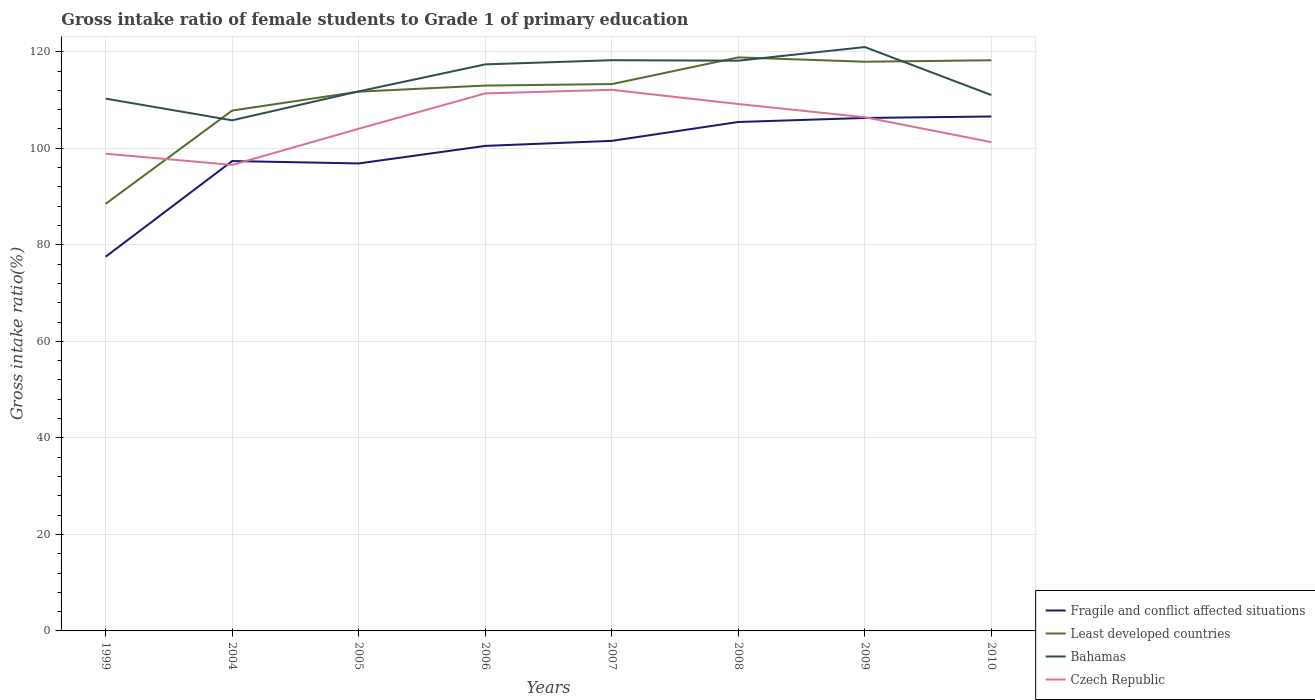Does the line corresponding to Bahamas intersect with the line corresponding to Fragile and conflict affected situations?
Your answer should be very brief. No. Across all years, what is the maximum gross intake ratio in Czech Republic?
Your answer should be compact. 96.55. What is the total gross intake ratio in Fragile and conflict affected situations in the graph?
Your answer should be very brief. -22.96. What is the difference between the highest and the second highest gross intake ratio in Fragile and conflict affected situations?
Ensure brevity in your answer.  29.05. How many lines are there?
Ensure brevity in your answer.  4. What is the difference between two consecutive major ticks on the Y-axis?
Keep it short and to the point. 20. Does the graph contain grids?
Ensure brevity in your answer.  Yes. How many legend labels are there?
Give a very brief answer. 4. What is the title of the graph?
Your response must be concise. Gross intake ratio of female students to Grade 1 of primary education. Does "Mauritius" appear as one of the legend labels in the graph?
Make the answer very short. No. What is the label or title of the X-axis?
Offer a terse response. Years. What is the label or title of the Y-axis?
Your answer should be very brief. Gross intake ratio(%). What is the Gross intake ratio(%) of Fragile and conflict affected situations in 1999?
Your response must be concise. 77.53. What is the Gross intake ratio(%) of Least developed countries in 1999?
Provide a short and direct response. 88.5. What is the Gross intake ratio(%) of Bahamas in 1999?
Give a very brief answer. 110.28. What is the Gross intake ratio(%) in Czech Republic in 1999?
Ensure brevity in your answer.  98.87. What is the Gross intake ratio(%) in Fragile and conflict affected situations in 2004?
Your response must be concise. 97.35. What is the Gross intake ratio(%) of Least developed countries in 2004?
Your answer should be compact. 107.81. What is the Gross intake ratio(%) of Bahamas in 2004?
Provide a short and direct response. 105.79. What is the Gross intake ratio(%) of Czech Republic in 2004?
Your response must be concise. 96.55. What is the Gross intake ratio(%) in Fragile and conflict affected situations in 2005?
Offer a very short reply. 96.86. What is the Gross intake ratio(%) in Least developed countries in 2005?
Provide a short and direct response. 111.72. What is the Gross intake ratio(%) of Bahamas in 2005?
Offer a terse response. 111.79. What is the Gross intake ratio(%) of Czech Republic in 2005?
Offer a terse response. 104.04. What is the Gross intake ratio(%) in Fragile and conflict affected situations in 2006?
Ensure brevity in your answer.  100.49. What is the Gross intake ratio(%) in Least developed countries in 2006?
Your answer should be very brief. 112.99. What is the Gross intake ratio(%) of Bahamas in 2006?
Your answer should be very brief. 117.38. What is the Gross intake ratio(%) of Czech Republic in 2006?
Your answer should be compact. 111.36. What is the Gross intake ratio(%) in Fragile and conflict affected situations in 2007?
Keep it short and to the point. 101.53. What is the Gross intake ratio(%) in Least developed countries in 2007?
Provide a succinct answer. 113.3. What is the Gross intake ratio(%) in Bahamas in 2007?
Offer a terse response. 118.24. What is the Gross intake ratio(%) of Czech Republic in 2007?
Your answer should be compact. 112.11. What is the Gross intake ratio(%) of Fragile and conflict affected situations in 2008?
Give a very brief answer. 105.44. What is the Gross intake ratio(%) in Least developed countries in 2008?
Provide a succinct answer. 118.83. What is the Gross intake ratio(%) in Bahamas in 2008?
Provide a short and direct response. 118.14. What is the Gross intake ratio(%) of Czech Republic in 2008?
Provide a succinct answer. 109.16. What is the Gross intake ratio(%) in Fragile and conflict affected situations in 2009?
Your answer should be very brief. 106.28. What is the Gross intake ratio(%) in Least developed countries in 2009?
Make the answer very short. 117.93. What is the Gross intake ratio(%) in Bahamas in 2009?
Your answer should be very brief. 120.97. What is the Gross intake ratio(%) in Czech Republic in 2009?
Offer a very short reply. 106.43. What is the Gross intake ratio(%) of Fragile and conflict affected situations in 2010?
Offer a very short reply. 106.58. What is the Gross intake ratio(%) of Least developed countries in 2010?
Keep it short and to the point. 118.23. What is the Gross intake ratio(%) of Bahamas in 2010?
Offer a terse response. 111.02. What is the Gross intake ratio(%) of Czech Republic in 2010?
Your answer should be compact. 101.27. Across all years, what is the maximum Gross intake ratio(%) in Fragile and conflict affected situations?
Your answer should be very brief. 106.58. Across all years, what is the maximum Gross intake ratio(%) in Least developed countries?
Your answer should be very brief. 118.83. Across all years, what is the maximum Gross intake ratio(%) in Bahamas?
Ensure brevity in your answer.  120.97. Across all years, what is the maximum Gross intake ratio(%) of Czech Republic?
Your answer should be very brief. 112.11. Across all years, what is the minimum Gross intake ratio(%) in Fragile and conflict affected situations?
Ensure brevity in your answer.  77.53. Across all years, what is the minimum Gross intake ratio(%) of Least developed countries?
Provide a succinct answer. 88.5. Across all years, what is the minimum Gross intake ratio(%) of Bahamas?
Provide a succinct answer. 105.79. Across all years, what is the minimum Gross intake ratio(%) in Czech Republic?
Your response must be concise. 96.55. What is the total Gross intake ratio(%) of Fragile and conflict affected situations in the graph?
Keep it short and to the point. 792.07. What is the total Gross intake ratio(%) in Least developed countries in the graph?
Give a very brief answer. 889.3. What is the total Gross intake ratio(%) of Bahamas in the graph?
Ensure brevity in your answer.  913.61. What is the total Gross intake ratio(%) of Czech Republic in the graph?
Give a very brief answer. 839.79. What is the difference between the Gross intake ratio(%) in Fragile and conflict affected situations in 1999 and that in 2004?
Ensure brevity in your answer.  -19.82. What is the difference between the Gross intake ratio(%) in Least developed countries in 1999 and that in 2004?
Your answer should be compact. -19.31. What is the difference between the Gross intake ratio(%) of Bahamas in 1999 and that in 2004?
Give a very brief answer. 4.49. What is the difference between the Gross intake ratio(%) of Czech Republic in 1999 and that in 2004?
Offer a very short reply. 2.31. What is the difference between the Gross intake ratio(%) of Fragile and conflict affected situations in 1999 and that in 2005?
Your answer should be compact. -19.32. What is the difference between the Gross intake ratio(%) in Least developed countries in 1999 and that in 2005?
Your answer should be compact. -23.22. What is the difference between the Gross intake ratio(%) in Bahamas in 1999 and that in 2005?
Offer a terse response. -1.51. What is the difference between the Gross intake ratio(%) in Czech Republic in 1999 and that in 2005?
Offer a terse response. -5.17. What is the difference between the Gross intake ratio(%) of Fragile and conflict affected situations in 1999 and that in 2006?
Provide a succinct answer. -22.96. What is the difference between the Gross intake ratio(%) in Least developed countries in 1999 and that in 2006?
Offer a terse response. -24.49. What is the difference between the Gross intake ratio(%) in Bahamas in 1999 and that in 2006?
Your answer should be compact. -7.1. What is the difference between the Gross intake ratio(%) in Czech Republic in 1999 and that in 2006?
Ensure brevity in your answer.  -12.5. What is the difference between the Gross intake ratio(%) in Fragile and conflict affected situations in 1999 and that in 2007?
Make the answer very short. -24. What is the difference between the Gross intake ratio(%) in Least developed countries in 1999 and that in 2007?
Offer a terse response. -24.8. What is the difference between the Gross intake ratio(%) of Bahamas in 1999 and that in 2007?
Offer a very short reply. -7.96. What is the difference between the Gross intake ratio(%) of Czech Republic in 1999 and that in 2007?
Your answer should be very brief. -13.24. What is the difference between the Gross intake ratio(%) of Fragile and conflict affected situations in 1999 and that in 2008?
Give a very brief answer. -27.91. What is the difference between the Gross intake ratio(%) in Least developed countries in 1999 and that in 2008?
Provide a short and direct response. -30.33. What is the difference between the Gross intake ratio(%) of Bahamas in 1999 and that in 2008?
Keep it short and to the point. -7.86. What is the difference between the Gross intake ratio(%) in Czech Republic in 1999 and that in 2008?
Keep it short and to the point. -10.29. What is the difference between the Gross intake ratio(%) of Fragile and conflict affected situations in 1999 and that in 2009?
Offer a terse response. -28.75. What is the difference between the Gross intake ratio(%) in Least developed countries in 1999 and that in 2009?
Your response must be concise. -29.43. What is the difference between the Gross intake ratio(%) of Bahamas in 1999 and that in 2009?
Your response must be concise. -10.69. What is the difference between the Gross intake ratio(%) of Czech Republic in 1999 and that in 2009?
Keep it short and to the point. -7.56. What is the difference between the Gross intake ratio(%) of Fragile and conflict affected situations in 1999 and that in 2010?
Give a very brief answer. -29.05. What is the difference between the Gross intake ratio(%) in Least developed countries in 1999 and that in 2010?
Make the answer very short. -29.73. What is the difference between the Gross intake ratio(%) of Bahamas in 1999 and that in 2010?
Offer a very short reply. -0.74. What is the difference between the Gross intake ratio(%) of Czech Republic in 1999 and that in 2010?
Keep it short and to the point. -2.41. What is the difference between the Gross intake ratio(%) of Fragile and conflict affected situations in 2004 and that in 2005?
Your answer should be very brief. 0.49. What is the difference between the Gross intake ratio(%) in Least developed countries in 2004 and that in 2005?
Your answer should be very brief. -3.91. What is the difference between the Gross intake ratio(%) in Bahamas in 2004 and that in 2005?
Your response must be concise. -6. What is the difference between the Gross intake ratio(%) of Czech Republic in 2004 and that in 2005?
Offer a very short reply. -7.49. What is the difference between the Gross intake ratio(%) of Fragile and conflict affected situations in 2004 and that in 2006?
Your answer should be compact. -3.14. What is the difference between the Gross intake ratio(%) in Least developed countries in 2004 and that in 2006?
Provide a short and direct response. -5.18. What is the difference between the Gross intake ratio(%) in Bahamas in 2004 and that in 2006?
Offer a terse response. -11.59. What is the difference between the Gross intake ratio(%) of Czech Republic in 2004 and that in 2006?
Keep it short and to the point. -14.81. What is the difference between the Gross intake ratio(%) in Fragile and conflict affected situations in 2004 and that in 2007?
Keep it short and to the point. -4.18. What is the difference between the Gross intake ratio(%) of Least developed countries in 2004 and that in 2007?
Offer a terse response. -5.48. What is the difference between the Gross intake ratio(%) of Bahamas in 2004 and that in 2007?
Keep it short and to the point. -12.46. What is the difference between the Gross intake ratio(%) in Czech Republic in 2004 and that in 2007?
Make the answer very short. -15.55. What is the difference between the Gross intake ratio(%) in Fragile and conflict affected situations in 2004 and that in 2008?
Ensure brevity in your answer.  -8.09. What is the difference between the Gross intake ratio(%) in Least developed countries in 2004 and that in 2008?
Your response must be concise. -11.01. What is the difference between the Gross intake ratio(%) of Bahamas in 2004 and that in 2008?
Ensure brevity in your answer.  -12.36. What is the difference between the Gross intake ratio(%) in Czech Republic in 2004 and that in 2008?
Keep it short and to the point. -12.6. What is the difference between the Gross intake ratio(%) in Fragile and conflict affected situations in 2004 and that in 2009?
Your response must be concise. -8.93. What is the difference between the Gross intake ratio(%) in Least developed countries in 2004 and that in 2009?
Ensure brevity in your answer.  -10.12. What is the difference between the Gross intake ratio(%) in Bahamas in 2004 and that in 2009?
Your response must be concise. -15.18. What is the difference between the Gross intake ratio(%) in Czech Republic in 2004 and that in 2009?
Offer a very short reply. -9.87. What is the difference between the Gross intake ratio(%) of Fragile and conflict affected situations in 2004 and that in 2010?
Offer a very short reply. -9.23. What is the difference between the Gross intake ratio(%) of Least developed countries in 2004 and that in 2010?
Offer a terse response. -10.42. What is the difference between the Gross intake ratio(%) in Bahamas in 2004 and that in 2010?
Offer a very short reply. -5.24. What is the difference between the Gross intake ratio(%) of Czech Republic in 2004 and that in 2010?
Keep it short and to the point. -4.72. What is the difference between the Gross intake ratio(%) in Fragile and conflict affected situations in 2005 and that in 2006?
Your response must be concise. -3.63. What is the difference between the Gross intake ratio(%) in Least developed countries in 2005 and that in 2006?
Your response must be concise. -1.27. What is the difference between the Gross intake ratio(%) in Bahamas in 2005 and that in 2006?
Your response must be concise. -5.59. What is the difference between the Gross intake ratio(%) in Czech Republic in 2005 and that in 2006?
Ensure brevity in your answer.  -7.32. What is the difference between the Gross intake ratio(%) in Fragile and conflict affected situations in 2005 and that in 2007?
Your answer should be compact. -4.68. What is the difference between the Gross intake ratio(%) of Least developed countries in 2005 and that in 2007?
Make the answer very short. -1.57. What is the difference between the Gross intake ratio(%) of Bahamas in 2005 and that in 2007?
Your answer should be very brief. -6.46. What is the difference between the Gross intake ratio(%) in Czech Republic in 2005 and that in 2007?
Keep it short and to the point. -8.07. What is the difference between the Gross intake ratio(%) of Fragile and conflict affected situations in 2005 and that in 2008?
Offer a very short reply. -8.59. What is the difference between the Gross intake ratio(%) in Least developed countries in 2005 and that in 2008?
Your answer should be compact. -7.1. What is the difference between the Gross intake ratio(%) of Bahamas in 2005 and that in 2008?
Keep it short and to the point. -6.36. What is the difference between the Gross intake ratio(%) of Czech Republic in 2005 and that in 2008?
Provide a short and direct response. -5.11. What is the difference between the Gross intake ratio(%) of Fragile and conflict affected situations in 2005 and that in 2009?
Give a very brief answer. -9.42. What is the difference between the Gross intake ratio(%) of Least developed countries in 2005 and that in 2009?
Your answer should be compact. -6.21. What is the difference between the Gross intake ratio(%) in Bahamas in 2005 and that in 2009?
Your answer should be compact. -9.18. What is the difference between the Gross intake ratio(%) in Czech Republic in 2005 and that in 2009?
Your answer should be very brief. -2.39. What is the difference between the Gross intake ratio(%) in Fragile and conflict affected situations in 2005 and that in 2010?
Provide a short and direct response. -9.73. What is the difference between the Gross intake ratio(%) in Least developed countries in 2005 and that in 2010?
Your answer should be compact. -6.51. What is the difference between the Gross intake ratio(%) in Bahamas in 2005 and that in 2010?
Your answer should be compact. 0.76. What is the difference between the Gross intake ratio(%) in Czech Republic in 2005 and that in 2010?
Make the answer very short. 2.77. What is the difference between the Gross intake ratio(%) in Fragile and conflict affected situations in 2006 and that in 2007?
Keep it short and to the point. -1.04. What is the difference between the Gross intake ratio(%) of Least developed countries in 2006 and that in 2007?
Your answer should be compact. -0.31. What is the difference between the Gross intake ratio(%) of Bahamas in 2006 and that in 2007?
Offer a very short reply. -0.87. What is the difference between the Gross intake ratio(%) in Czech Republic in 2006 and that in 2007?
Give a very brief answer. -0.74. What is the difference between the Gross intake ratio(%) of Fragile and conflict affected situations in 2006 and that in 2008?
Provide a succinct answer. -4.95. What is the difference between the Gross intake ratio(%) in Least developed countries in 2006 and that in 2008?
Your answer should be compact. -5.83. What is the difference between the Gross intake ratio(%) in Bahamas in 2006 and that in 2008?
Your answer should be compact. -0.76. What is the difference between the Gross intake ratio(%) in Czech Republic in 2006 and that in 2008?
Make the answer very short. 2.21. What is the difference between the Gross intake ratio(%) in Fragile and conflict affected situations in 2006 and that in 2009?
Provide a succinct answer. -5.79. What is the difference between the Gross intake ratio(%) of Least developed countries in 2006 and that in 2009?
Keep it short and to the point. -4.94. What is the difference between the Gross intake ratio(%) of Bahamas in 2006 and that in 2009?
Offer a terse response. -3.59. What is the difference between the Gross intake ratio(%) in Czech Republic in 2006 and that in 2009?
Offer a terse response. 4.94. What is the difference between the Gross intake ratio(%) in Fragile and conflict affected situations in 2006 and that in 2010?
Your answer should be very brief. -6.09. What is the difference between the Gross intake ratio(%) of Least developed countries in 2006 and that in 2010?
Provide a succinct answer. -5.24. What is the difference between the Gross intake ratio(%) in Bahamas in 2006 and that in 2010?
Your answer should be compact. 6.35. What is the difference between the Gross intake ratio(%) in Czech Republic in 2006 and that in 2010?
Ensure brevity in your answer.  10.09. What is the difference between the Gross intake ratio(%) of Fragile and conflict affected situations in 2007 and that in 2008?
Your answer should be compact. -3.91. What is the difference between the Gross intake ratio(%) of Least developed countries in 2007 and that in 2008?
Your response must be concise. -5.53. What is the difference between the Gross intake ratio(%) in Bahamas in 2007 and that in 2008?
Your answer should be very brief. 0.1. What is the difference between the Gross intake ratio(%) in Czech Republic in 2007 and that in 2008?
Ensure brevity in your answer.  2.95. What is the difference between the Gross intake ratio(%) of Fragile and conflict affected situations in 2007 and that in 2009?
Keep it short and to the point. -4.75. What is the difference between the Gross intake ratio(%) in Least developed countries in 2007 and that in 2009?
Keep it short and to the point. -4.63. What is the difference between the Gross intake ratio(%) in Bahamas in 2007 and that in 2009?
Provide a short and direct response. -2.72. What is the difference between the Gross intake ratio(%) of Czech Republic in 2007 and that in 2009?
Ensure brevity in your answer.  5.68. What is the difference between the Gross intake ratio(%) of Fragile and conflict affected situations in 2007 and that in 2010?
Provide a succinct answer. -5.05. What is the difference between the Gross intake ratio(%) in Least developed countries in 2007 and that in 2010?
Your response must be concise. -4.93. What is the difference between the Gross intake ratio(%) in Bahamas in 2007 and that in 2010?
Keep it short and to the point. 7.22. What is the difference between the Gross intake ratio(%) in Czech Republic in 2007 and that in 2010?
Keep it short and to the point. 10.83. What is the difference between the Gross intake ratio(%) in Fragile and conflict affected situations in 2008 and that in 2009?
Ensure brevity in your answer.  -0.84. What is the difference between the Gross intake ratio(%) of Least developed countries in 2008 and that in 2009?
Give a very brief answer. 0.9. What is the difference between the Gross intake ratio(%) in Bahamas in 2008 and that in 2009?
Make the answer very short. -2.82. What is the difference between the Gross intake ratio(%) of Czech Republic in 2008 and that in 2009?
Ensure brevity in your answer.  2.73. What is the difference between the Gross intake ratio(%) in Fragile and conflict affected situations in 2008 and that in 2010?
Your answer should be compact. -1.14. What is the difference between the Gross intake ratio(%) of Least developed countries in 2008 and that in 2010?
Your response must be concise. 0.6. What is the difference between the Gross intake ratio(%) in Bahamas in 2008 and that in 2010?
Your answer should be very brief. 7.12. What is the difference between the Gross intake ratio(%) of Czech Republic in 2008 and that in 2010?
Provide a succinct answer. 7.88. What is the difference between the Gross intake ratio(%) in Fragile and conflict affected situations in 2009 and that in 2010?
Offer a terse response. -0.3. What is the difference between the Gross intake ratio(%) in Least developed countries in 2009 and that in 2010?
Offer a terse response. -0.3. What is the difference between the Gross intake ratio(%) in Bahamas in 2009 and that in 2010?
Your answer should be compact. 9.94. What is the difference between the Gross intake ratio(%) in Czech Republic in 2009 and that in 2010?
Make the answer very short. 5.15. What is the difference between the Gross intake ratio(%) in Fragile and conflict affected situations in 1999 and the Gross intake ratio(%) in Least developed countries in 2004?
Give a very brief answer. -30.28. What is the difference between the Gross intake ratio(%) in Fragile and conflict affected situations in 1999 and the Gross intake ratio(%) in Bahamas in 2004?
Provide a succinct answer. -28.26. What is the difference between the Gross intake ratio(%) of Fragile and conflict affected situations in 1999 and the Gross intake ratio(%) of Czech Republic in 2004?
Provide a succinct answer. -19.02. What is the difference between the Gross intake ratio(%) of Least developed countries in 1999 and the Gross intake ratio(%) of Bahamas in 2004?
Keep it short and to the point. -17.29. What is the difference between the Gross intake ratio(%) in Least developed countries in 1999 and the Gross intake ratio(%) in Czech Republic in 2004?
Your answer should be very brief. -8.05. What is the difference between the Gross intake ratio(%) in Bahamas in 1999 and the Gross intake ratio(%) in Czech Republic in 2004?
Offer a very short reply. 13.73. What is the difference between the Gross intake ratio(%) in Fragile and conflict affected situations in 1999 and the Gross intake ratio(%) in Least developed countries in 2005?
Provide a succinct answer. -34.19. What is the difference between the Gross intake ratio(%) in Fragile and conflict affected situations in 1999 and the Gross intake ratio(%) in Bahamas in 2005?
Offer a very short reply. -34.26. What is the difference between the Gross intake ratio(%) in Fragile and conflict affected situations in 1999 and the Gross intake ratio(%) in Czech Republic in 2005?
Offer a terse response. -26.51. What is the difference between the Gross intake ratio(%) of Least developed countries in 1999 and the Gross intake ratio(%) of Bahamas in 2005?
Your response must be concise. -23.29. What is the difference between the Gross intake ratio(%) of Least developed countries in 1999 and the Gross intake ratio(%) of Czech Republic in 2005?
Provide a succinct answer. -15.54. What is the difference between the Gross intake ratio(%) in Bahamas in 1999 and the Gross intake ratio(%) in Czech Republic in 2005?
Provide a succinct answer. 6.24. What is the difference between the Gross intake ratio(%) in Fragile and conflict affected situations in 1999 and the Gross intake ratio(%) in Least developed countries in 2006?
Offer a terse response. -35.46. What is the difference between the Gross intake ratio(%) of Fragile and conflict affected situations in 1999 and the Gross intake ratio(%) of Bahamas in 2006?
Your answer should be very brief. -39.85. What is the difference between the Gross intake ratio(%) of Fragile and conflict affected situations in 1999 and the Gross intake ratio(%) of Czech Republic in 2006?
Make the answer very short. -33.83. What is the difference between the Gross intake ratio(%) in Least developed countries in 1999 and the Gross intake ratio(%) in Bahamas in 2006?
Ensure brevity in your answer.  -28.88. What is the difference between the Gross intake ratio(%) of Least developed countries in 1999 and the Gross intake ratio(%) of Czech Republic in 2006?
Give a very brief answer. -22.87. What is the difference between the Gross intake ratio(%) in Bahamas in 1999 and the Gross intake ratio(%) in Czech Republic in 2006?
Provide a short and direct response. -1.08. What is the difference between the Gross intake ratio(%) in Fragile and conflict affected situations in 1999 and the Gross intake ratio(%) in Least developed countries in 2007?
Offer a terse response. -35.76. What is the difference between the Gross intake ratio(%) of Fragile and conflict affected situations in 1999 and the Gross intake ratio(%) of Bahamas in 2007?
Keep it short and to the point. -40.71. What is the difference between the Gross intake ratio(%) of Fragile and conflict affected situations in 1999 and the Gross intake ratio(%) of Czech Republic in 2007?
Make the answer very short. -34.58. What is the difference between the Gross intake ratio(%) of Least developed countries in 1999 and the Gross intake ratio(%) of Bahamas in 2007?
Provide a short and direct response. -29.75. What is the difference between the Gross intake ratio(%) of Least developed countries in 1999 and the Gross intake ratio(%) of Czech Republic in 2007?
Your answer should be very brief. -23.61. What is the difference between the Gross intake ratio(%) in Bahamas in 1999 and the Gross intake ratio(%) in Czech Republic in 2007?
Your answer should be compact. -1.83. What is the difference between the Gross intake ratio(%) of Fragile and conflict affected situations in 1999 and the Gross intake ratio(%) of Least developed countries in 2008?
Keep it short and to the point. -41.29. What is the difference between the Gross intake ratio(%) of Fragile and conflict affected situations in 1999 and the Gross intake ratio(%) of Bahamas in 2008?
Provide a short and direct response. -40.61. What is the difference between the Gross intake ratio(%) in Fragile and conflict affected situations in 1999 and the Gross intake ratio(%) in Czech Republic in 2008?
Ensure brevity in your answer.  -31.63. What is the difference between the Gross intake ratio(%) of Least developed countries in 1999 and the Gross intake ratio(%) of Bahamas in 2008?
Keep it short and to the point. -29.64. What is the difference between the Gross intake ratio(%) of Least developed countries in 1999 and the Gross intake ratio(%) of Czech Republic in 2008?
Make the answer very short. -20.66. What is the difference between the Gross intake ratio(%) in Bahamas in 1999 and the Gross intake ratio(%) in Czech Republic in 2008?
Give a very brief answer. 1.12. What is the difference between the Gross intake ratio(%) in Fragile and conflict affected situations in 1999 and the Gross intake ratio(%) in Least developed countries in 2009?
Offer a very short reply. -40.4. What is the difference between the Gross intake ratio(%) of Fragile and conflict affected situations in 1999 and the Gross intake ratio(%) of Bahamas in 2009?
Make the answer very short. -43.44. What is the difference between the Gross intake ratio(%) in Fragile and conflict affected situations in 1999 and the Gross intake ratio(%) in Czech Republic in 2009?
Provide a succinct answer. -28.9. What is the difference between the Gross intake ratio(%) of Least developed countries in 1999 and the Gross intake ratio(%) of Bahamas in 2009?
Provide a short and direct response. -32.47. What is the difference between the Gross intake ratio(%) in Least developed countries in 1999 and the Gross intake ratio(%) in Czech Republic in 2009?
Your answer should be very brief. -17.93. What is the difference between the Gross intake ratio(%) of Bahamas in 1999 and the Gross intake ratio(%) of Czech Republic in 2009?
Provide a succinct answer. 3.85. What is the difference between the Gross intake ratio(%) in Fragile and conflict affected situations in 1999 and the Gross intake ratio(%) in Least developed countries in 2010?
Your answer should be very brief. -40.7. What is the difference between the Gross intake ratio(%) of Fragile and conflict affected situations in 1999 and the Gross intake ratio(%) of Bahamas in 2010?
Your answer should be very brief. -33.49. What is the difference between the Gross intake ratio(%) of Fragile and conflict affected situations in 1999 and the Gross intake ratio(%) of Czech Republic in 2010?
Provide a succinct answer. -23.74. What is the difference between the Gross intake ratio(%) of Least developed countries in 1999 and the Gross intake ratio(%) of Bahamas in 2010?
Provide a succinct answer. -22.52. What is the difference between the Gross intake ratio(%) of Least developed countries in 1999 and the Gross intake ratio(%) of Czech Republic in 2010?
Provide a short and direct response. -12.77. What is the difference between the Gross intake ratio(%) in Bahamas in 1999 and the Gross intake ratio(%) in Czech Republic in 2010?
Ensure brevity in your answer.  9.01. What is the difference between the Gross intake ratio(%) of Fragile and conflict affected situations in 2004 and the Gross intake ratio(%) of Least developed countries in 2005?
Provide a short and direct response. -14.37. What is the difference between the Gross intake ratio(%) in Fragile and conflict affected situations in 2004 and the Gross intake ratio(%) in Bahamas in 2005?
Provide a short and direct response. -14.44. What is the difference between the Gross intake ratio(%) in Fragile and conflict affected situations in 2004 and the Gross intake ratio(%) in Czech Republic in 2005?
Offer a very short reply. -6.69. What is the difference between the Gross intake ratio(%) of Least developed countries in 2004 and the Gross intake ratio(%) of Bahamas in 2005?
Make the answer very short. -3.97. What is the difference between the Gross intake ratio(%) of Least developed countries in 2004 and the Gross intake ratio(%) of Czech Republic in 2005?
Your answer should be compact. 3.77. What is the difference between the Gross intake ratio(%) in Bahamas in 2004 and the Gross intake ratio(%) in Czech Republic in 2005?
Provide a short and direct response. 1.75. What is the difference between the Gross intake ratio(%) of Fragile and conflict affected situations in 2004 and the Gross intake ratio(%) of Least developed countries in 2006?
Your response must be concise. -15.64. What is the difference between the Gross intake ratio(%) in Fragile and conflict affected situations in 2004 and the Gross intake ratio(%) in Bahamas in 2006?
Provide a short and direct response. -20.03. What is the difference between the Gross intake ratio(%) of Fragile and conflict affected situations in 2004 and the Gross intake ratio(%) of Czech Republic in 2006?
Your answer should be compact. -14.01. What is the difference between the Gross intake ratio(%) in Least developed countries in 2004 and the Gross intake ratio(%) in Bahamas in 2006?
Your answer should be compact. -9.56. What is the difference between the Gross intake ratio(%) in Least developed countries in 2004 and the Gross intake ratio(%) in Czech Republic in 2006?
Your response must be concise. -3.55. What is the difference between the Gross intake ratio(%) in Bahamas in 2004 and the Gross intake ratio(%) in Czech Republic in 2006?
Keep it short and to the point. -5.58. What is the difference between the Gross intake ratio(%) in Fragile and conflict affected situations in 2004 and the Gross intake ratio(%) in Least developed countries in 2007?
Make the answer very short. -15.95. What is the difference between the Gross intake ratio(%) in Fragile and conflict affected situations in 2004 and the Gross intake ratio(%) in Bahamas in 2007?
Ensure brevity in your answer.  -20.89. What is the difference between the Gross intake ratio(%) of Fragile and conflict affected situations in 2004 and the Gross intake ratio(%) of Czech Republic in 2007?
Offer a very short reply. -14.76. What is the difference between the Gross intake ratio(%) of Least developed countries in 2004 and the Gross intake ratio(%) of Bahamas in 2007?
Provide a short and direct response. -10.43. What is the difference between the Gross intake ratio(%) of Least developed countries in 2004 and the Gross intake ratio(%) of Czech Republic in 2007?
Offer a terse response. -4.29. What is the difference between the Gross intake ratio(%) of Bahamas in 2004 and the Gross intake ratio(%) of Czech Republic in 2007?
Your response must be concise. -6.32. What is the difference between the Gross intake ratio(%) of Fragile and conflict affected situations in 2004 and the Gross intake ratio(%) of Least developed countries in 2008?
Your answer should be very brief. -21.48. What is the difference between the Gross intake ratio(%) in Fragile and conflict affected situations in 2004 and the Gross intake ratio(%) in Bahamas in 2008?
Give a very brief answer. -20.79. What is the difference between the Gross intake ratio(%) in Fragile and conflict affected situations in 2004 and the Gross intake ratio(%) in Czech Republic in 2008?
Your answer should be compact. -11.81. What is the difference between the Gross intake ratio(%) in Least developed countries in 2004 and the Gross intake ratio(%) in Bahamas in 2008?
Your answer should be very brief. -10.33. What is the difference between the Gross intake ratio(%) in Least developed countries in 2004 and the Gross intake ratio(%) in Czech Republic in 2008?
Offer a very short reply. -1.34. What is the difference between the Gross intake ratio(%) of Bahamas in 2004 and the Gross intake ratio(%) of Czech Republic in 2008?
Your response must be concise. -3.37. What is the difference between the Gross intake ratio(%) of Fragile and conflict affected situations in 2004 and the Gross intake ratio(%) of Least developed countries in 2009?
Your answer should be compact. -20.58. What is the difference between the Gross intake ratio(%) of Fragile and conflict affected situations in 2004 and the Gross intake ratio(%) of Bahamas in 2009?
Offer a terse response. -23.62. What is the difference between the Gross intake ratio(%) in Fragile and conflict affected situations in 2004 and the Gross intake ratio(%) in Czech Republic in 2009?
Ensure brevity in your answer.  -9.08. What is the difference between the Gross intake ratio(%) in Least developed countries in 2004 and the Gross intake ratio(%) in Bahamas in 2009?
Your answer should be very brief. -13.15. What is the difference between the Gross intake ratio(%) of Least developed countries in 2004 and the Gross intake ratio(%) of Czech Republic in 2009?
Keep it short and to the point. 1.39. What is the difference between the Gross intake ratio(%) of Bahamas in 2004 and the Gross intake ratio(%) of Czech Republic in 2009?
Your response must be concise. -0.64. What is the difference between the Gross intake ratio(%) of Fragile and conflict affected situations in 2004 and the Gross intake ratio(%) of Least developed countries in 2010?
Your response must be concise. -20.88. What is the difference between the Gross intake ratio(%) of Fragile and conflict affected situations in 2004 and the Gross intake ratio(%) of Bahamas in 2010?
Make the answer very short. -13.67. What is the difference between the Gross intake ratio(%) in Fragile and conflict affected situations in 2004 and the Gross intake ratio(%) in Czech Republic in 2010?
Make the answer very short. -3.92. What is the difference between the Gross intake ratio(%) of Least developed countries in 2004 and the Gross intake ratio(%) of Bahamas in 2010?
Your answer should be compact. -3.21. What is the difference between the Gross intake ratio(%) of Least developed countries in 2004 and the Gross intake ratio(%) of Czech Republic in 2010?
Ensure brevity in your answer.  6.54. What is the difference between the Gross intake ratio(%) in Bahamas in 2004 and the Gross intake ratio(%) in Czech Republic in 2010?
Your answer should be very brief. 4.51. What is the difference between the Gross intake ratio(%) in Fragile and conflict affected situations in 2005 and the Gross intake ratio(%) in Least developed countries in 2006?
Your answer should be compact. -16.14. What is the difference between the Gross intake ratio(%) in Fragile and conflict affected situations in 2005 and the Gross intake ratio(%) in Bahamas in 2006?
Keep it short and to the point. -20.52. What is the difference between the Gross intake ratio(%) of Fragile and conflict affected situations in 2005 and the Gross intake ratio(%) of Czech Republic in 2006?
Provide a short and direct response. -14.51. What is the difference between the Gross intake ratio(%) in Least developed countries in 2005 and the Gross intake ratio(%) in Bahamas in 2006?
Offer a very short reply. -5.66. What is the difference between the Gross intake ratio(%) in Least developed countries in 2005 and the Gross intake ratio(%) in Czech Republic in 2006?
Your answer should be compact. 0.36. What is the difference between the Gross intake ratio(%) in Bahamas in 2005 and the Gross intake ratio(%) in Czech Republic in 2006?
Keep it short and to the point. 0.42. What is the difference between the Gross intake ratio(%) in Fragile and conflict affected situations in 2005 and the Gross intake ratio(%) in Least developed countries in 2007?
Make the answer very short. -16.44. What is the difference between the Gross intake ratio(%) in Fragile and conflict affected situations in 2005 and the Gross intake ratio(%) in Bahamas in 2007?
Your answer should be very brief. -21.39. What is the difference between the Gross intake ratio(%) of Fragile and conflict affected situations in 2005 and the Gross intake ratio(%) of Czech Republic in 2007?
Offer a very short reply. -15.25. What is the difference between the Gross intake ratio(%) in Least developed countries in 2005 and the Gross intake ratio(%) in Bahamas in 2007?
Your answer should be very brief. -6.52. What is the difference between the Gross intake ratio(%) in Least developed countries in 2005 and the Gross intake ratio(%) in Czech Republic in 2007?
Your answer should be compact. -0.38. What is the difference between the Gross intake ratio(%) of Bahamas in 2005 and the Gross intake ratio(%) of Czech Republic in 2007?
Keep it short and to the point. -0.32. What is the difference between the Gross intake ratio(%) of Fragile and conflict affected situations in 2005 and the Gross intake ratio(%) of Least developed countries in 2008?
Ensure brevity in your answer.  -21.97. What is the difference between the Gross intake ratio(%) in Fragile and conflict affected situations in 2005 and the Gross intake ratio(%) in Bahamas in 2008?
Offer a terse response. -21.29. What is the difference between the Gross intake ratio(%) in Fragile and conflict affected situations in 2005 and the Gross intake ratio(%) in Czech Republic in 2008?
Offer a very short reply. -12.3. What is the difference between the Gross intake ratio(%) of Least developed countries in 2005 and the Gross intake ratio(%) of Bahamas in 2008?
Make the answer very short. -6.42. What is the difference between the Gross intake ratio(%) of Least developed countries in 2005 and the Gross intake ratio(%) of Czech Republic in 2008?
Provide a succinct answer. 2.57. What is the difference between the Gross intake ratio(%) in Bahamas in 2005 and the Gross intake ratio(%) in Czech Republic in 2008?
Your answer should be compact. 2.63. What is the difference between the Gross intake ratio(%) of Fragile and conflict affected situations in 2005 and the Gross intake ratio(%) of Least developed countries in 2009?
Your answer should be very brief. -21.07. What is the difference between the Gross intake ratio(%) in Fragile and conflict affected situations in 2005 and the Gross intake ratio(%) in Bahamas in 2009?
Provide a short and direct response. -24.11. What is the difference between the Gross intake ratio(%) in Fragile and conflict affected situations in 2005 and the Gross intake ratio(%) in Czech Republic in 2009?
Your answer should be very brief. -9.57. What is the difference between the Gross intake ratio(%) of Least developed countries in 2005 and the Gross intake ratio(%) of Bahamas in 2009?
Offer a terse response. -9.24. What is the difference between the Gross intake ratio(%) of Least developed countries in 2005 and the Gross intake ratio(%) of Czech Republic in 2009?
Your answer should be very brief. 5.29. What is the difference between the Gross intake ratio(%) in Bahamas in 2005 and the Gross intake ratio(%) in Czech Republic in 2009?
Give a very brief answer. 5.36. What is the difference between the Gross intake ratio(%) in Fragile and conflict affected situations in 2005 and the Gross intake ratio(%) in Least developed countries in 2010?
Keep it short and to the point. -21.37. What is the difference between the Gross intake ratio(%) of Fragile and conflict affected situations in 2005 and the Gross intake ratio(%) of Bahamas in 2010?
Your answer should be compact. -14.17. What is the difference between the Gross intake ratio(%) in Fragile and conflict affected situations in 2005 and the Gross intake ratio(%) in Czech Republic in 2010?
Offer a terse response. -4.42. What is the difference between the Gross intake ratio(%) of Least developed countries in 2005 and the Gross intake ratio(%) of Bahamas in 2010?
Provide a short and direct response. 0.7. What is the difference between the Gross intake ratio(%) of Least developed countries in 2005 and the Gross intake ratio(%) of Czech Republic in 2010?
Make the answer very short. 10.45. What is the difference between the Gross intake ratio(%) in Bahamas in 2005 and the Gross intake ratio(%) in Czech Republic in 2010?
Make the answer very short. 10.51. What is the difference between the Gross intake ratio(%) in Fragile and conflict affected situations in 2006 and the Gross intake ratio(%) in Least developed countries in 2007?
Provide a succinct answer. -12.81. What is the difference between the Gross intake ratio(%) in Fragile and conflict affected situations in 2006 and the Gross intake ratio(%) in Bahamas in 2007?
Your answer should be compact. -17.75. What is the difference between the Gross intake ratio(%) in Fragile and conflict affected situations in 2006 and the Gross intake ratio(%) in Czech Republic in 2007?
Make the answer very short. -11.62. What is the difference between the Gross intake ratio(%) of Least developed countries in 2006 and the Gross intake ratio(%) of Bahamas in 2007?
Offer a terse response. -5.25. What is the difference between the Gross intake ratio(%) in Least developed countries in 2006 and the Gross intake ratio(%) in Czech Republic in 2007?
Make the answer very short. 0.88. What is the difference between the Gross intake ratio(%) in Bahamas in 2006 and the Gross intake ratio(%) in Czech Republic in 2007?
Provide a succinct answer. 5.27. What is the difference between the Gross intake ratio(%) of Fragile and conflict affected situations in 2006 and the Gross intake ratio(%) of Least developed countries in 2008?
Ensure brevity in your answer.  -18.34. What is the difference between the Gross intake ratio(%) in Fragile and conflict affected situations in 2006 and the Gross intake ratio(%) in Bahamas in 2008?
Provide a succinct answer. -17.65. What is the difference between the Gross intake ratio(%) of Fragile and conflict affected situations in 2006 and the Gross intake ratio(%) of Czech Republic in 2008?
Provide a short and direct response. -8.67. What is the difference between the Gross intake ratio(%) of Least developed countries in 2006 and the Gross intake ratio(%) of Bahamas in 2008?
Offer a very short reply. -5.15. What is the difference between the Gross intake ratio(%) of Least developed countries in 2006 and the Gross intake ratio(%) of Czech Republic in 2008?
Ensure brevity in your answer.  3.83. What is the difference between the Gross intake ratio(%) of Bahamas in 2006 and the Gross intake ratio(%) of Czech Republic in 2008?
Your answer should be very brief. 8.22. What is the difference between the Gross intake ratio(%) of Fragile and conflict affected situations in 2006 and the Gross intake ratio(%) of Least developed countries in 2009?
Provide a short and direct response. -17.44. What is the difference between the Gross intake ratio(%) in Fragile and conflict affected situations in 2006 and the Gross intake ratio(%) in Bahamas in 2009?
Give a very brief answer. -20.48. What is the difference between the Gross intake ratio(%) in Fragile and conflict affected situations in 2006 and the Gross intake ratio(%) in Czech Republic in 2009?
Provide a short and direct response. -5.94. What is the difference between the Gross intake ratio(%) in Least developed countries in 2006 and the Gross intake ratio(%) in Bahamas in 2009?
Your answer should be very brief. -7.98. What is the difference between the Gross intake ratio(%) in Least developed countries in 2006 and the Gross intake ratio(%) in Czech Republic in 2009?
Keep it short and to the point. 6.56. What is the difference between the Gross intake ratio(%) in Bahamas in 2006 and the Gross intake ratio(%) in Czech Republic in 2009?
Offer a very short reply. 10.95. What is the difference between the Gross intake ratio(%) in Fragile and conflict affected situations in 2006 and the Gross intake ratio(%) in Least developed countries in 2010?
Your answer should be very brief. -17.74. What is the difference between the Gross intake ratio(%) in Fragile and conflict affected situations in 2006 and the Gross intake ratio(%) in Bahamas in 2010?
Your answer should be compact. -10.53. What is the difference between the Gross intake ratio(%) in Fragile and conflict affected situations in 2006 and the Gross intake ratio(%) in Czech Republic in 2010?
Give a very brief answer. -0.78. What is the difference between the Gross intake ratio(%) of Least developed countries in 2006 and the Gross intake ratio(%) of Bahamas in 2010?
Make the answer very short. 1.97. What is the difference between the Gross intake ratio(%) of Least developed countries in 2006 and the Gross intake ratio(%) of Czech Republic in 2010?
Offer a terse response. 11.72. What is the difference between the Gross intake ratio(%) in Bahamas in 2006 and the Gross intake ratio(%) in Czech Republic in 2010?
Ensure brevity in your answer.  16.1. What is the difference between the Gross intake ratio(%) in Fragile and conflict affected situations in 2007 and the Gross intake ratio(%) in Least developed countries in 2008?
Make the answer very short. -17.29. What is the difference between the Gross intake ratio(%) of Fragile and conflict affected situations in 2007 and the Gross intake ratio(%) of Bahamas in 2008?
Make the answer very short. -16.61. What is the difference between the Gross intake ratio(%) in Fragile and conflict affected situations in 2007 and the Gross intake ratio(%) in Czech Republic in 2008?
Give a very brief answer. -7.62. What is the difference between the Gross intake ratio(%) of Least developed countries in 2007 and the Gross intake ratio(%) of Bahamas in 2008?
Offer a terse response. -4.85. What is the difference between the Gross intake ratio(%) in Least developed countries in 2007 and the Gross intake ratio(%) in Czech Republic in 2008?
Make the answer very short. 4.14. What is the difference between the Gross intake ratio(%) in Bahamas in 2007 and the Gross intake ratio(%) in Czech Republic in 2008?
Your answer should be compact. 9.09. What is the difference between the Gross intake ratio(%) in Fragile and conflict affected situations in 2007 and the Gross intake ratio(%) in Least developed countries in 2009?
Provide a short and direct response. -16.39. What is the difference between the Gross intake ratio(%) in Fragile and conflict affected situations in 2007 and the Gross intake ratio(%) in Bahamas in 2009?
Give a very brief answer. -19.43. What is the difference between the Gross intake ratio(%) in Fragile and conflict affected situations in 2007 and the Gross intake ratio(%) in Czech Republic in 2009?
Keep it short and to the point. -4.89. What is the difference between the Gross intake ratio(%) in Least developed countries in 2007 and the Gross intake ratio(%) in Bahamas in 2009?
Offer a terse response. -7.67. What is the difference between the Gross intake ratio(%) of Least developed countries in 2007 and the Gross intake ratio(%) of Czech Republic in 2009?
Your answer should be compact. 6.87. What is the difference between the Gross intake ratio(%) in Bahamas in 2007 and the Gross intake ratio(%) in Czech Republic in 2009?
Offer a terse response. 11.82. What is the difference between the Gross intake ratio(%) in Fragile and conflict affected situations in 2007 and the Gross intake ratio(%) in Least developed countries in 2010?
Keep it short and to the point. -16.7. What is the difference between the Gross intake ratio(%) in Fragile and conflict affected situations in 2007 and the Gross intake ratio(%) in Bahamas in 2010?
Provide a succinct answer. -9.49. What is the difference between the Gross intake ratio(%) of Fragile and conflict affected situations in 2007 and the Gross intake ratio(%) of Czech Republic in 2010?
Your answer should be very brief. 0.26. What is the difference between the Gross intake ratio(%) in Least developed countries in 2007 and the Gross intake ratio(%) in Bahamas in 2010?
Keep it short and to the point. 2.27. What is the difference between the Gross intake ratio(%) in Least developed countries in 2007 and the Gross intake ratio(%) in Czech Republic in 2010?
Offer a terse response. 12.02. What is the difference between the Gross intake ratio(%) in Bahamas in 2007 and the Gross intake ratio(%) in Czech Republic in 2010?
Provide a short and direct response. 16.97. What is the difference between the Gross intake ratio(%) of Fragile and conflict affected situations in 2008 and the Gross intake ratio(%) of Least developed countries in 2009?
Ensure brevity in your answer.  -12.49. What is the difference between the Gross intake ratio(%) of Fragile and conflict affected situations in 2008 and the Gross intake ratio(%) of Bahamas in 2009?
Give a very brief answer. -15.52. What is the difference between the Gross intake ratio(%) in Fragile and conflict affected situations in 2008 and the Gross intake ratio(%) in Czech Republic in 2009?
Provide a short and direct response. -0.99. What is the difference between the Gross intake ratio(%) of Least developed countries in 2008 and the Gross intake ratio(%) of Bahamas in 2009?
Keep it short and to the point. -2.14. What is the difference between the Gross intake ratio(%) of Least developed countries in 2008 and the Gross intake ratio(%) of Czech Republic in 2009?
Provide a succinct answer. 12.4. What is the difference between the Gross intake ratio(%) in Bahamas in 2008 and the Gross intake ratio(%) in Czech Republic in 2009?
Offer a very short reply. 11.71. What is the difference between the Gross intake ratio(%) of Fragile and conflict affected situations in 2008 and the Gross intake ratio(%) of Least developed countries in 2010?
Give a very brief answer. -12.79. What is the difference between the Gross intake ratio(%) in Fragile and conflict affected situations in 2008 and the Gross intake ratio(%) in Bahamas in 2010?
Offer a very short reply. -5.58. What is the difference between the Gross intake ratio(%) of Fragile and conflict affected situations in 2008 and the Gross intake ratio(%) of Czech Republic in 2010?
Your response must be concise. 4.17. What is the difference between the Gross intake ratio(%) in Least developed countries in 2008 and the Gross intake ratio(%) in Bahamas in 2010?
Provide a short and direct response. 7.8. What is the difference between the Gross intake ratio(%) of Least developed countries in 2008 and the Gross intake ratio(%) of Czech Republic in 2010?
Offer a terse response. 17.55. What is the difference between the Gross intake ratio(%) of Bahamas in 2008 and the Gross intake ratio(%) of Czech Republic in 2010?
Make the answer very short. 16.87. What is the difference between the Gross intake ratio(%) in Fragile and conflict affected situations in 2009 and the Gross intake ratio(%) in Least developed countries in 2010?
Your answer should be very brief. -11.95. What is the difference between the Gross intake ratio(%) in Fragile and conflict affected situations in 2009 and the Gross intake ratio(%) in Bahamas in 2010?
Give a very brief answer. -4.74. What is the difference between the Gross intake ratio(%) of Fragile and conflict affected situations in 2009 and the Gross intake ratio(%) of Czech Republic in 2010?
Your response must be concise. 5.01. What is the difference between the Gross intake ratio(%) in Least developed countries in 2009 and the Gross intake ratio(%) in Bahamas in 2010?
Keep it short and to the point. 6.91. What is the difference between the Gross intake ratio(%) of Least developed countries in 2009 and the Gross intake ratio(%) of Czech Republic in 2010?
Provide a short and direct response. 16.66. What is the difference between the Gross intake ratio(%) in Bahamas in 2009 and the Gross intake ratio(%) in Czech Republic in 2010?
Keep it short and to the point. 19.69. What is the average Gross intake ratio(%) in Fragile and conflict affected situations per year?
Ensure brevity in your answer.  99.01. What is the average Gross intake ratio(%) in Least developed countries per year?
Provide a succinct answer. 111.16. What is the average Gross intake ratio(%) in Bahamas per year?
Ensure brevity in your answer.  114.2. What is the average Gross intake ratio(%) in Czech Republic per year?
Make the answer very short. 104.97. In the year 1999, what is the difference between the Gross intake ratio(%) in Fragile and conflict affected situations and Gross intake ratio(%) in Least developed countries?
Provide a succinct answer. -10.97. In the year 1999, what is the difference between the Gross intake ratio(%) of Fragile and conflict affected situations and Gross intake ratio(%) of Bahamas?
Your answer should be very brief. -32.75. In the year 1999, what is the difference between the Gross intake ratio(%) of Fragile and conflict affected situations and Gross intake ratio(%) of Czech Republic?
Provide a succinct answer. -21.34. In the year 1999, what is the difference between the Gross intake ratio(%) in Least developed countries and Gross intake ratio(%) in Bahamas?
Give a very brief answer. -21.78. In the year 1999, what is the difference between the Gross intake ratio(%) in Least developed countries and Gross intake ratio(%) in Czech Republic?
Offer a terse response. -10.37. In the year 1999, what is the difference between the Gross intake ratio(%) in Bahamas and Gross intake ratio(%) in Czech Republic?
Offer a very short reply. 11.41. In the year 2004, what is the difference between the Gross intake ratio(%) of Fragile and conflict affected situations and Gross intake ratio(%) of Least developed countries?
Provide a short and direct response. -10.46. In the year 2004, what is the difference between the Gross intake ratio(%) of Fragile and conflict affected situations and Gross intake ratio(%) of Bahamas?
Offer a terse response. -8.44. In the year 2004, what is the difference between the Gross intake ratio(%) in Fragile and conflict affected situations and Gross intake ratio(%) in Czech Republic?
Offer a very short reply. 0.8. In the year 2004, what is the difference between the Gross intake ratio(%) in Least developed countries and Gross intake ratio(%) in Bahamas?
Your answer should be compact. 2.03. In the year 2004, what is the difference between the Gross intake ratio(%) in Least developed countries and Gross intake ratio(%) in Czech Republic?
Ensure brevity in your answer.  11.26. In the year 2004, what is the difference between the Gross intake ratio(%) in Bahamas and Gross intake ratio(%) in Czech Republic?
Offer a terse response. 9.23. In the year 2005, what is the difference between the Gross intake ratio(%) in Fragile and conflict affected situations and Gross intake ratio(%) in Least developed countries?
Give a very brief answer. -14.87. In the year 2005, what is the difference between the Gross intake ratio(%) of Fragile and conflict affected situations and Gross intake ratio(%) of Bahamas?
Keep it short and to the point. -14.93. In the year 2005, what is the difference between the Gross intake ratio(%) in Fragile and conflict affected situations and Gross intake ratio(%) in Czech Republic?
Your response must be concise. -7.19. In the year 2005, what is the difference between the Gross intake ratio(%) in Least developed countries and Gross intake ratio(%) in Bahamas?
Offer a terse response. -0.06. In the year 2005, what is the difference between the Gross intake ratio(%) of Least developed countries and Gross intake ratio(%) of Czech Republic?
Offer a terse response. 7.68. In the year 2005, what is the difference between the Gross intake ratio(%) of Bahamas and Gross intake ratio(%) of Czech Republic?
Your response must be concise. 7.74. In the year 2006, what is the difference between the Gross intake ratio(%) in Fragile and conflict affected situations and Gross intake ratio(%) in Least developed countries?
Offer a terse response. -12.5. In the year 2006, what is the difference between the Gross intake ratio(%) in Fragile and conflict affected situations and Gross intake ratio(%) in Bahamas?
Make the answer very short. -16.89. In the year 2006, what is the difference between the Gross intake ratio(%) of Fragile and conflict affected situations and Gross intake ratio(%) of Czech Republic?
Provide a succinct answer. -10.88. In the year 2006, what is the difference between the Gross intake ratio(%) in Least developed countries and Gross intake ratio(%) in Bahamas?
Make the answer very short. -4.39. In the year 2006, what is the difference between the Gross intake ratio(%) of Least developed countries and Gross intake ratio(%) of Czech Republic?
Keep it short and to the point. 1.63. In the year 2006, what is the difference between the Gross intake ratio(%) of Bahamas and Gross intake ratio(%) of Czech Republic?
Provide a short and direct response. 6.01. In the year 2007, what is the difference between the Gross intake ratio(%) in Fragile and conflict affected situations and Gross intake ratio(%) in Least developed countries?
Your response must be concise. -11.76. In the year 2007, what is the difference between the Gross intake ratio(%) in Fragile and conflict affected situations and Gross intake ratio(%) in Bahamas?
Your answer should be very brief. -16.71. In the year 2007, what is the difference between the Gross intake ratio(%) of Fragile and conflict affected situations and Gross intake ratio(%) of Czech Republic?
Your answer should be very brief. -10.57. In the year 2007, what is the difference between the Gross intake ratio(%) of Least developed countries and Gross intake ratio(%) of Bahamas?
Offer a very short reply. -4.95. In the year 2007, what is the difference between the Gross intake ratio(%) in Least developed countries and Gross intake ratio(%) in Czech Republic?
Give a very brief answer. 1.19. In the year 2007, what is the difference between the Gross intake ratio(%) of Bahamas and Gross intake ratio(%) of Czech Republic?
Your answer should be compact. 6.14. In the year 2008, what is the difference between the Gross intake ratio(%) in Fragile and conflict affected situations and Gross intake ratio(%) in Least developed countries?
Keep it short and to the point. -13.38. In the year 2008, what is the difference between the Gross intake ratio(%) in Fragile and conflict affected situations and Gross intake ratio(%) in Bahamas?
Provide a succinct answer. -12.7. In the year 2008, what is the difference between the Gross intake ratio(%) in Fragile and conflict affected situations and Gross intake ratio(%) in Czech Republic?
Your response must be concise. -3.71. In the year 2008, what is the difference between the Gross intake ratio(%) in Least developed countries and Gross intake ratio(%) in Bahamas?
Provide a succinct answer. 0.68. In the year 2008, what is the difference between the Gross intake ratio(%) of Least developed countries and Gross intake ratio(%) of Czech Republic?
Offer a terse response. 9.67. In the year 2008, what is the difference between the Gross intake ratio(%) of Bahamas and Gross intake ratio(%) of Czech Republic?
Your answer should be compact. 8.99. In the year 2009, what is the difference between the Gross intake ratio(%) of Fragile and conflict affected situations and Gross intake ratio(%) of Least developed countries?
Make the answer very short. -11.65. In the year 2009, what is the difference between the Gross intake ratio(%) of Fragile and conflict affected situations and Gross intake ratio(%) of Bahamas?
Keep it short and to the point. -14.69. In the year 2009, what is the difference between the Gross intake ratio(%) in Fragile and conflict affected situations and Gross intake ratio(%) in Czech Republic?
Your response must be concise. -0.15. In the year 2009, what is the difference between the Gross intake ratio(%) in Least developed countries and Gross intake ratio(%) in Bahamas?
Your answer should be compact. -3.04. In the year 2009, what is the difference between the Gross intake ratio(%) in Least developed countries and Gross intake ratio(%) in Czech Republic?
Ensure brevity in your answer.  11.5. In the year 2009, what is the difference between the Gross intake ratio(%) in Bahamas and Gross intake ratio(%) in Czech Republic?
Provide a succinct answer. 14.54. In the year 2010, what is the difference between the Gross intake ratio(%) in Fragile and conflict affected situations and Gross intake ratio(%) in Least developed countries?
Give a very brief answer. -11.65. In the year 2010, what is the difference between the Gross intake ratio(%) in Fragile and conflict affected situations and Gross intake ratio(%) in Bahamas?
Ensure brevity in your answer.  -4.44. In the year 2010, what is the difference between the Gross intake ratio(%) in Fragile and conflict affected situations and Gross intake ratio(%) in Czech Republic?
Your answer should be compact. 5.31. In the year 2010, what is the difference between the Gross intake ratio(%) of Least developed countries and Gross intake ratio(%) of Bahamas?
Your response must be concise. 7.21. In the year 2010, what is the difference between the Gross intake ratio(%) in Least developed countries and Gross intake ratio(%) in Czech Republic?
Make the answer very short. 16.96. In the year 2010, what is the difference between the Gross intake ratio(%) of Bahamas and Gross intake ratio(%) of Czech Republic?
Ensure brevity in your answer.  9.75. What is the ratio of the Gross intake ratio(%) in Fragile and conflict affected situations in 1999 to that in 2004?
Keep it short and to the point. 0.8. What is the ratio of the Gross intake ratio(%) in Least developed countries in 1999 to that in 2004?
Provide a succinct answer. 0.82. What is the ratio of the Gross intake ratio(%) of Bahamas in 1999 to that in 2004?
Offer a terse response. 1.04. What is the ratio of the Gross intake ratio(%) of Czech Republic in 1999 to that in 2004?
Keep it short and to the point. 1.02. What is the ratio of the Gross intake ratio(%) of Fragile and conflict affected situations in 1999 to that in 2005?
Provide a succinct answer. 0.8. What is the ratio of the Gross intake ratio(%) of Least developed countries in 1999 to that in 2005?
Make the answer very short. 0.79. What is the ratio of the Gross intake ratio(%) of Bahamas in 1999 to that in 2005?
Your response must be concise. 0.99. What is the ratio of the Gross intake ratio(%) in Czech Republic in 1999 to that in 2005?
Offer a very short reply. 0.95. What is the ratio of the Gross intake ratio(%) in Fragile and conflict affected situations in 1999 to that in 2006?
Your response must be concise. 0.77. What is the ratio of the Gross intake ratio(%) of Least developed countries in 1999 to that in 2006?
Give a very brief answer. 0.78. What is the ratio of the Gross intake ratio(%) in Bahamas in 1999 to that in 2006?
Keep it short and to the point. 0.94. What is the ratio of the Gross intake ratio(%) of Czech Republic in 1999 to that in 2006?
Make the answer very short. 0.89. What is the ratio of the Gross intake ratio(%) in Fragile and conflict affected situations in 1999 to that in 2007?
Provide a succinct answer. 0.76. What is the ratio of the Gross intake ratio(%) of Least developed countries in 1999 to that in 2007?
Provide a short and direct response. 0.78. What is the ratio of the Gross intake ratio(%) of Bahamas in 1999 to that in 2007?
Keep it short and to the point. 0.93. What is the ratio of the Gross intake ratio(%) of Czech Republic in 1999 to that in 2007?
Offer a terse response. 0.88. What is the ratio of the Gross intake ratio(%) in Fragile and conflict affected situations in 1999 to that in 2008?
Make the answer very short. 0.74. What is the ratio of the Gross intake ratio(%) in Least developed countries in 1999 to that in 2008?
Make the answer very short. 0.74. What is the ratio of the Gross intake ratio(%) of Bahamas in 1999 to that in 2008?
Make the answer very short. 0.93. What is the ratio of the Gross intake ratio(%) in Czech Republic in 1999 to that in 2008?
Offer a very short reply. 0.91. What is the ratio of the Gross intake ratio(%) in Fragile and conflict affected situations in 1999 to that in 2009?
Ensure brevity in your answer.  0.73. What is the ratio of the Gross intake ratio(%) of Least developed countries in 1999 to that in 2009?
Provide a succinct answer. 0.75. What is the ratio of the Gross intake ratio(%) in Bahamas in 1999 to that in 2009?
Keep it short and to the point. 0.91. What is the ratio of the Gross intake ratio(%) in Czech Republic in 1999 to that in 2009?
Provide a short and direct response. 0.93. What is the ratio of the Gross intake ratio(%) in Fragile and conflict affected situations in 1999 to that in 2010?
Ensure brevity in your answer.  0.73. What is the ratio of the Gross intake ratio(%) in Least developed countries in 1999 to that in 2010?
Provide a succinct answer. 0.75. What is the ratio of the Gross intake ratio(%) in Czech Republic in 1999 to that in 2010?
Keep it short and to the point. 0.98. What is the ratio of the Gross intake ratio(%) in Fragile and conflict affected situations in 2004 to that in 2005?
Offer a very short reply. 1.01. What is the ratio of the Gross intake ratio(%) of Bahamas in 2004 to that in 2005?
Keep it short and to the point. 0.95. What is the ratio of the Gross intake ratio(%) in Czech Republic in 2004 to that in 2005?
Your response must be concise. 0.93. What is the ratio of the Gross intake ratio(%) of Fragile and conflict affected situations in 2004 to that in 2006?
Ensure brevity in your answer.  0.97. What is the ratio of the Gross intake ratio(%) in Least developed countries in 2004 to that in 2006?
Offer a terse response. 0.95. What is the ratio of the Gross intake ratio(%) in Bahamas in 2004 to that in 2006?
Keep it short and to the point. 0.9. What is the ratio of the Gross intake ratio(%) of Czech Republic in 2004 to that in 2006?
Your response must be concise. 0.87. What is the ratio of the Gross intake ratio(%) of Fragile and conflict affected situations in 2004 to that in 2007?
Make the answer very short. 0.96. What is the ratio of the Gross intake ratio(%) in Least developed countries in 2004 to that in 2007?
Your answer should be very brief. 0.95. What is the ratio of the Gross intake ratio(%) of Bahamas in 2004 to that in 2007?
Make the answer very short. 0.89. What is the ratio of the Gross intake ratio(%) in Czech Republic in 2004 to that in 2007?
Keep it short and to the point. 0.86. What is the ratio of the Gross intake ratio(%) of Fragile and conflict affected situations in 2004 to that in 2008?
Offer a terse response. 0.92. What is the ratio of the Gross intake ratio(%) in Least developed countries in 2004 to that in 2008?
Provide a succinct answer. 0.91. What is the ratio of the Gross intake ratio(%) of Bahamas in 2004 to that in 2008?
Offer a terse response. 0.9. What is the ratio of the Gross intake ratio(%) in Czech Republic in 2004 to that in 2008?
Your response must be concise. 0.88. What is the ratio of the Gross intake ratio(%) of Fragile and conflict affected situations in 2004 to that in 2009?
Ensure brevity in your answer.  0.92. What is the ratio of the Gross intake ratio(%) of Least developed countries in 2004 to that in 2009?
Ensure brevity in your answer.  0.91. What is the ratio of the Gross intake ratio(%) of Bahamas in 2004 to that in 2009?
Provide a short and direct response. 0.87. What is the ratio of the Gross intake ratio(%) of Czech Republic in 2004 to that in 2009?
Give a very brief answer. 0.91. What is the ratio of the Gross intake ratio(%) in Fragile and conflict affected situations in 2004 to that in 2010?
Your answer should be compact. 0.91. What is the ratio of the Gross intake ratio(%) in Least developed countries in 2004 to that in 2010?
Offer a terse response. 0.91. What is the ratio of the Gross intake ratio(%) of Bahamas in 2004 to that in 2010?
Make the answer very short. 0.95. What is the ratio of the Gross intake ratio(%) in Czech Republic in 2004 to that in 2010?
Offer a terse response. 0.95. What is the ratio of the Gross intake ratio(%) of Fragile and conflict affected situations in 2005 to that in 2006?
Keep it short and to the point. 0.96. What is the ratio of the Gross intake ratio(%) of Least developed countries in 2005 to that in 2006?
Your response must be concise. 0.99. What is the ratio of the Gross intake ratio(%) of Bahamas in 2005 to that in 2006?
Your answer should be compact. 0.95. What is the ratio of the Gross intake ratio(%) in Czech Republic in 2005 to that in 2006?
Your answer should be very brief. 0.93. What is the ratio of the Gross intake ratio(%) in Fragile and conflict affected situations in 2005 to that in 2007?
Provide a short and direct response. 0.95. What is the ratio of the Gross intake ratio(%) of Least developed countries in 2005 to that in 2007?
Your answer should be compact. 0.99. What is the ratio of the Gross intake ratio(%) of Bahamas in 2005 to that in 2007?
Provide a short and direct response. 0.95. What is the ratio of the Gross intake ratio(%) of Czech Republic in 2005 to that in 2007?
Ensure brevity in your answer.  0.93. What is the ratio of the Gross intake ratio(%) in Fragile and conflict affected situations in 2005 to that in 2008?
Ensure brevity in your answer.  0.92. What is the ratio of the Gross intake ratio(%) in Least developed countries in 2005 to that in 2008?
Offer a terse response. 0.94. What is the ratio of the Gross intake ratio(%) in Bahamas in 2005 to that in 2008?
Ensure brevity in your answer.  0.95. What is the ratio of the Gross intake ratio(%) of Czech Republic in 2005 to that in 2008?
Provide a short and direct response. 0.95. What is the ratio of the Gross intake ratio(%) in Fragile and conflict affected situations in 2005 to that in 2009?
Your response must be concise. 0.91. What is the ratio of the Gross intake ratio(%) of Bahamas in 2005 to that in 2009?
Provide a succinct answer. 0.92. What is the ratio of the Gross intake ratio(%) of Czech Republic in 2005 to that in 2009?
Your response must be concise. 0.98. What is the ratio of the Gross intake ratio(%) of Fragile and conflict affected situations in 2005 to that in 2010?
Your answer should be very brief. 0.91. What is the ratio of the Gross intake ratio(%) of Least developed countries in 2005 to that in 2010?
Make the answer very short. 0.94. What is the ratio of the Gross intake ratio(%) of Czech Republic in 2005 to that in 2010?
Make the answer very short. 1.03. What is the ratio of the Gross intake ratio(%) in Fragile and conflict affected situations in 2006 to that in 2007?
Provide a short and direct response. 0.99. What is the ratio of the Gross intake ratio(%) of Least developed countries in 2006 to that in 2007?
Your answer should be very brief. 1. What is the ratio of the Gross intake ratio(%) in Fragile and conflict affected situations in 2006 to that in 2008?
Your response must be concise. 0.95. What is the ratio of the Gross intake ratio(%) in Least developed countries in 2006 to that in 2008?
Provide a succinct answer. 0.95. What is the ratio of the Gross intake ratio(%) of Bahamas in 2006 to that in 2008?
Offer a terse response. 0.99. What is the ratio of the Gross intake ratio(%) of Czech Republic in 2006 to that in 2008?
Provide a succinct answer. 1.02. What is the ratio of the Gross intake ratio(%) of Fragile and conflict affected situations in 2006 to that in 2009?
Your answer should be very brief. 0.95. What is the ratio of the Gross intake ratio(%) of Least developed countries in 2006 to that in 2009?
Offer a very short reply. 0.96. What is the ratio of the Gross intake ratio(%) of Bahamas in 2006 to that in 2009?
Give a very brief answer. 0.97. What is the ratio of the Gross intake ratio(%) in Czech Republic in 2006 to that in 2009?
Provide a succinct answer. 1.05. What is the ratio of the Gross intake ratio(%) of Fragile and conflict affected situations in 2006 to that in 2010?
Offer a very short reply. 0.94. What is the ratio of the Gross intake ratio(%) of Least developed countries in 2006 to that in 2010?
Give a very brief answer. 0.96. What is the ratio of the Gross intake ratio(%) of Bahamas in 2006 to that in 2010?
Your answer should be compact. 1.06. What is the ratio of the Gross intake ratio(%) in Czech Republic in 2006 to that in 2010?
Give a very brief answer. 1.1. What is the ratio of the Gross intake ratio(%) of Fragile and conflict affected situations in 2007 to that in 2008?
Offer a terse response. 0.96. What is the ratio of the Gross intake ratio(%) of Least developed countries in 2007 to that in 2008?
Offer a very short reply. 0.95. What is the ratio of the Gross intake ratio(%) in Fragile and conflict affected situations in 2007 to that in 2009?
Make the answer very short. 0.96. What is the ratio of the Gross intake ratio(%) of Least developed countries in 2007 to that in 2009?
Your response must be concise. 0.96. What is the ratio of the Gross intake ratio(%) in Bahamas in 2007 to that in 2009?
Your answer should be compact. 0.98. What is the ratio of the Gross intake ratio(%) of Czech Republic in 2007 to that in 2009?
Keep it short and to the point. 1.05. What is the ratio of the Gross intake ratio(%) of Fragile and conflict affected situations in 2007 to that in 2010?
Offer a very short reply. 0.95. What is the ratio of the Gross intake ratio(%) of Least developed countries in 2007 to that in 2010?
Offer a terse response. 0.96. What is the ratio of the Gross intake ratio(%) of Bahamas in 2007 to that in 2010?
Provide a succinct answer. 1.06. What is the ratio of the Gross intake ratio(%) in Czech Republic in 2007 to that in 2010?
Your answer should be very brief. 1.11. What is the ratio of the Gross intake ratio(%) in Least developed countries in 2008 to that in 2009?
Provide a short and direct response. 1.01. What is the ratio of the Gross intake ratio(%) of Bahamas in 2008 to that in 2009?
Give a very brief answer. 0.98. What is the ratio of the Gross intake ratio(%) of Czech Republic in 2008 to that in 2009?
Offer a terse response. 1.03. What is the ratio of the Gross intake ratio(%) in Fragile and conflict affected situations in 2008 to that in 2010?
Your answer should be very brief. 0.99. What is the ratio of the Gross intake ratio(%) of Bahamas in 2008 to that in 2010?
Give a very brief answer. 1.06. What is the ratio of the Gross intake ratio(%) of Czech Republic in 2008 to that in 2010?
Provide a succinct answer. 1.08. What is the ratio of the Gross intake ratio(%) of Bahamas in 2009 to that in 2010?
Keep it short and to the point. 1.09. What is the ratio of the Gross intake ratio(%) of Czech Republic in 2009 to that in 2010?
Keep it short and to the point. 1.05. What is the difference between the highest and the second highest Gross intake ratio(%) in Fragile and conflict affected situations?
Provide a short and direct response. 0.3. What is the difference between the highest and the second highest Gross intake ratio(%) in Least developed countries?
Offer a terse response. 0.6. What is the difference between the highest and the second highest Gross intake ratio(%) of Bahamas?
Provide a short and direct response. 2.72. What is the difference between the highest and the second highest Gross intake ratio(%) in Czech Republic?
Offer a very short reply. 0.74. What is the difference between the highest and the lowest Gross intake ratio(%) in Fragile and conflict affected situations?
Provide a short and direct response. 29.05. What is the difference between the highest and the lowest Gross intake ratio(%) in Least developed countries?
Your response must be concise. 30.33. What is the difference between the highest and the lowest Gross intake ratio(%) in Bahamas?
Offer a very short reply. 15.18. What is the difference between the highest and the lowest Gross intake ratio(%) in Czech Republic?
Give a very brief answer. 15.55. 